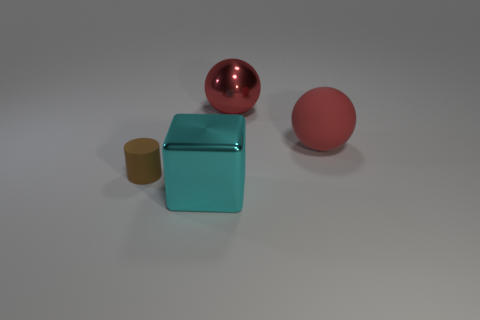Is the number of small brown things greater than the number of metallic objects? Upon reviewing the image, the number of small brown things, which in this case appears to be only one small brown cylinder, is not greater than the number of metallic objects. There are two metallic objects visible: one reflective red sphere and a teal cube that exhibits a metallic sheen suggesting it's a metal. So, the accurate response is that the number of metallic objects exceeds the number of small brown things. 